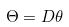Convert formula to latex. <formula><loc_0><loc_0><loc_500><loc_500>\Theta = D \theta</formula> 